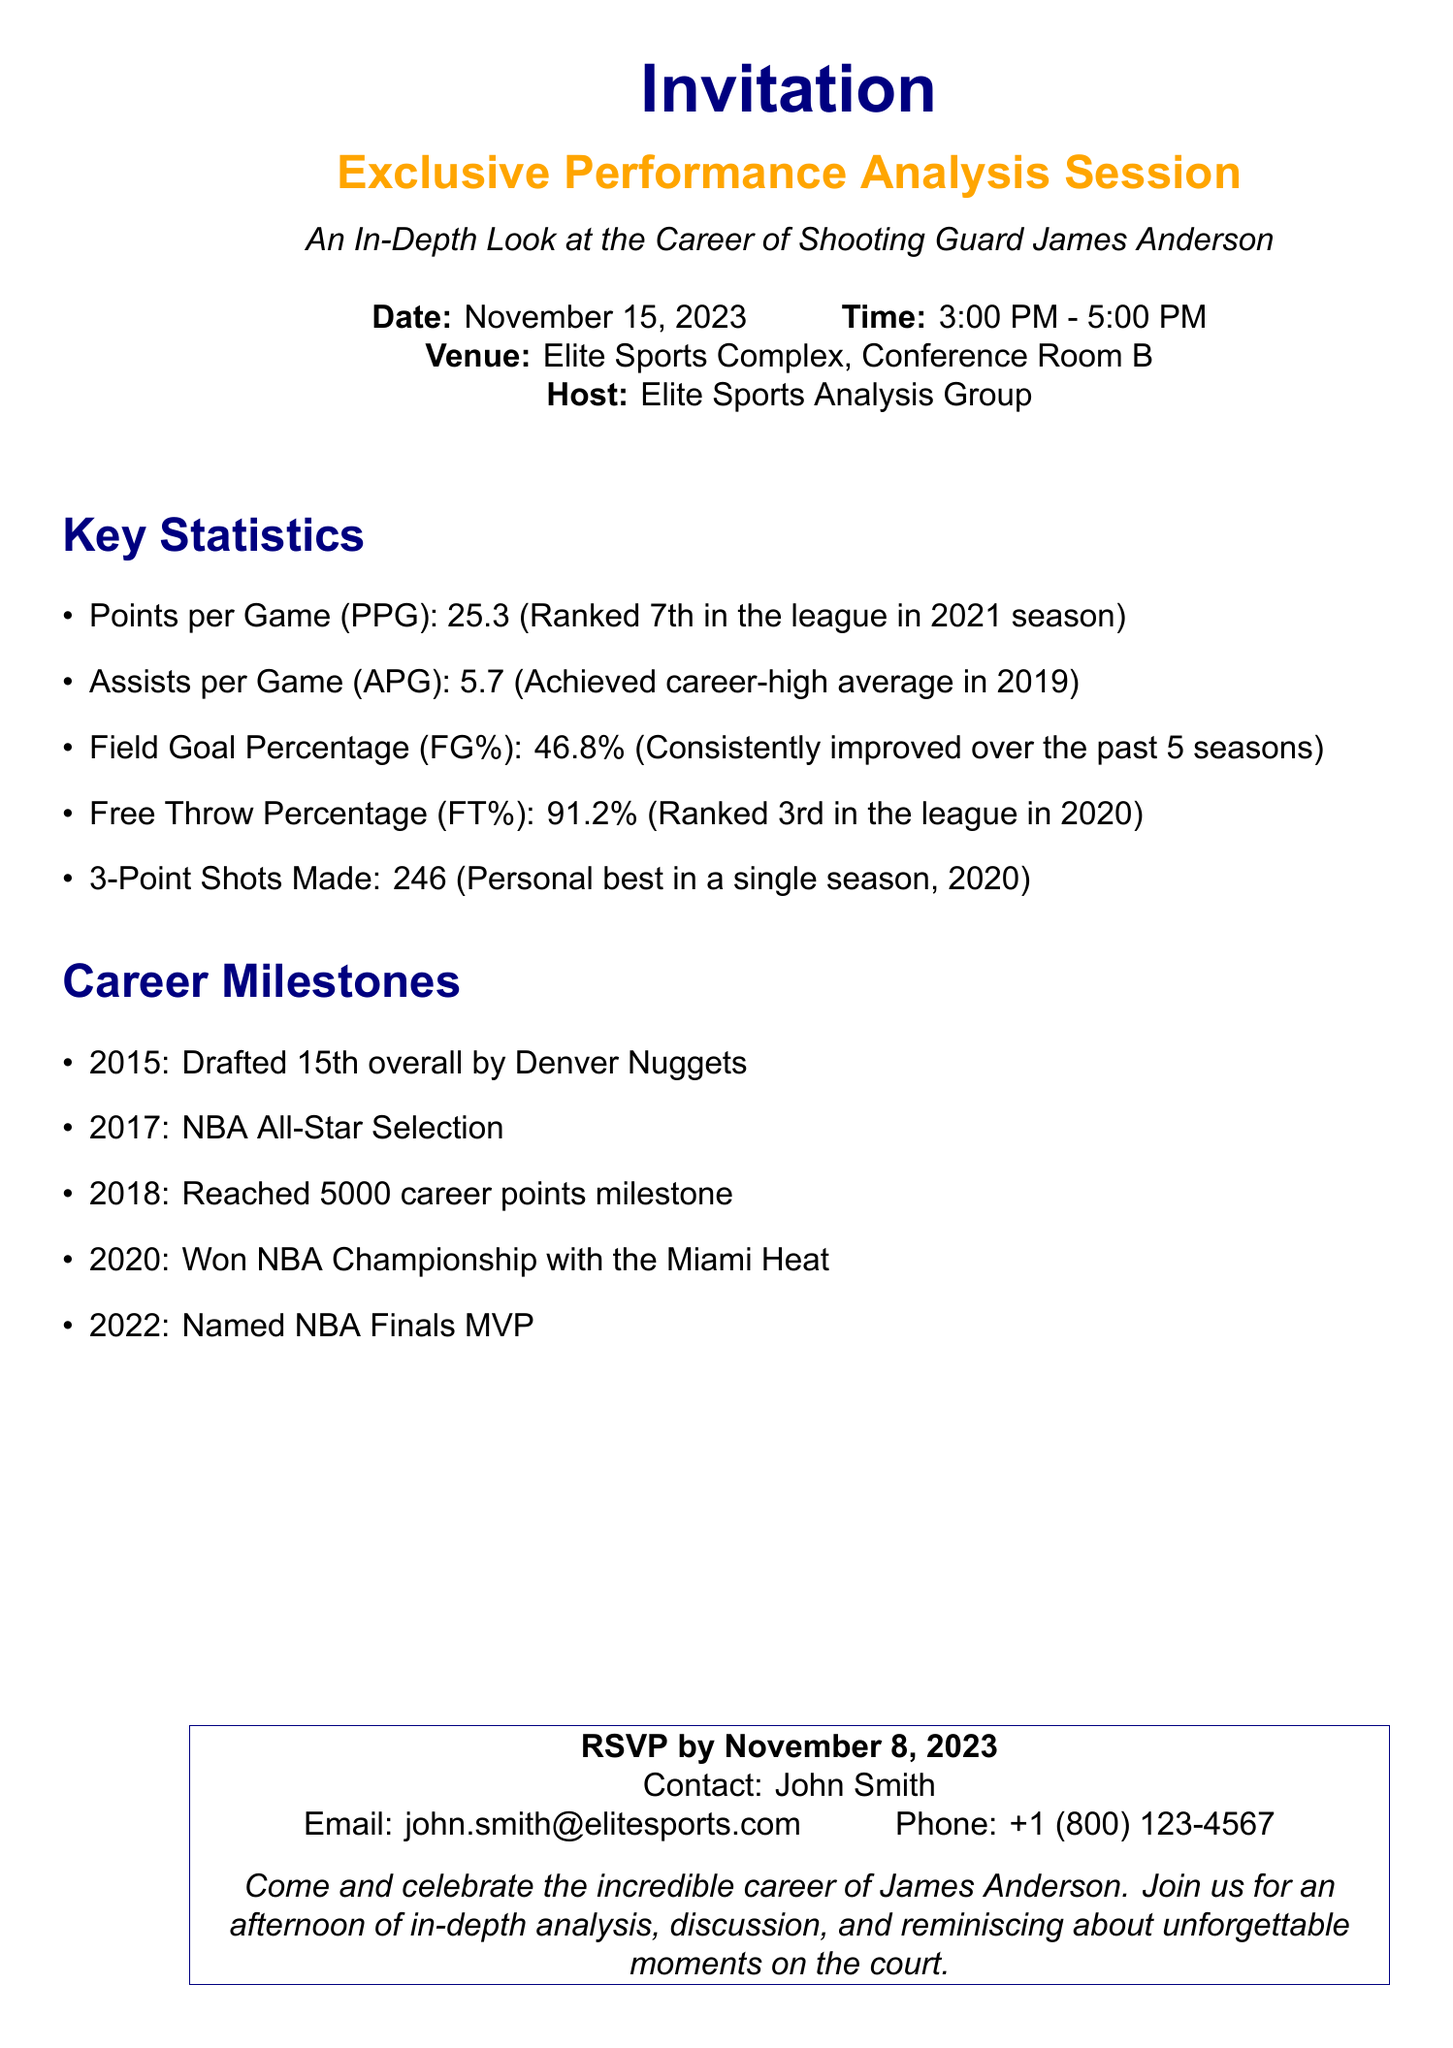What is the date of the event? The date of the event is specified in the document, which is November 15, 2023.
Answer: November 15, 2023 How many points per game did James Anderson average? The document lists the point average of James Anderson, which is 25.3 points per game.
Answer: 25.3 What was James Anderson's field goal percentage? The field goal percentage provided in the document shows James Anderson's accuracy at 46.8%.
Answer: 46.8% Which team did James Anderson win the NBA Championship with? The document mentions that James Anderson won the championship with the Miami Heat.
Answer: Miami Heat When was James Anderson drafted? The document states that James Anderson was drafted in the year 2015.
Answer: 2015 What was James Anderson ranked in the league for free throw percentage? The document indicates that he was ranked 3rd in the league for free throw percentage.
Answer: 3rd What is the email address to RSVP? The RSVP email address provided in the document is john.smith@elitesports.com.
Answer: john.smith@elitesports.com What is the time frame for the event? The document specifies the event's time frame as 3:00 PM - 5:00 PM.
Answer: 3:00 PM - 5:00 PM How many career points did James Anderson reach by 2018? According to the document, James Anderson reached 5000 career points milestone by 2018.
Answer: 5000 